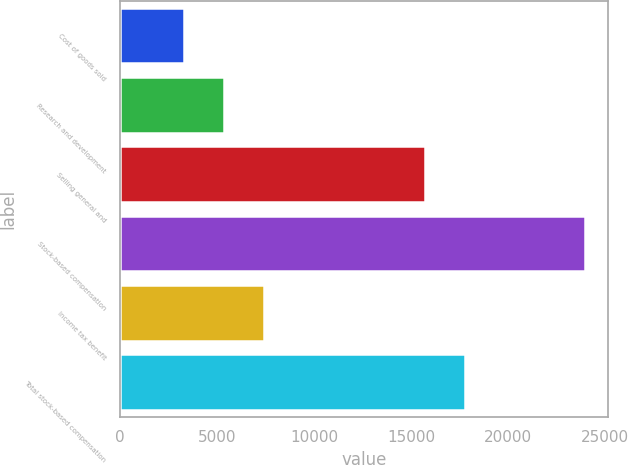Convert chart to OTSL. <chart><loc_0><loc_0><loc_500><loc_500><bar_chart><fcel>Cost of goods sold<fcel>Research and development<fcel>Selling general and<fcel>Stock-based compensation<fcel>Income tax benefit<fcel>Total stock-based compensation<nl><fcel>3297<fcel>5362.8<fcel>15715<fcel>23955<fcel>7428.6<fcel>17780.8<nl></chart> 